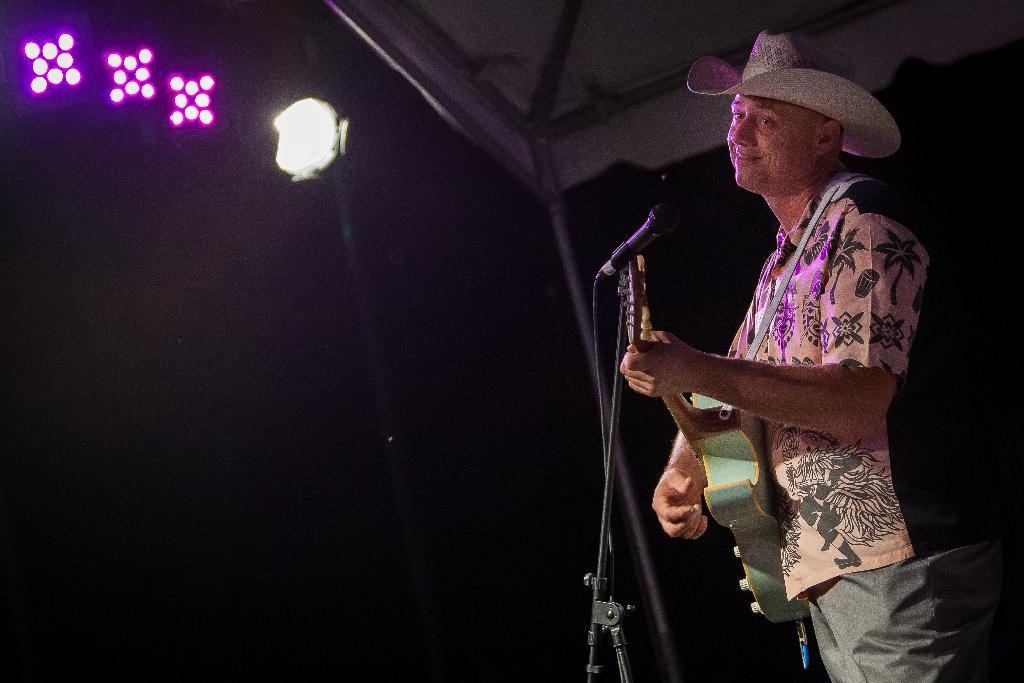What is the main subject of the image? The main subject of the image is a man. What is the man doing in the image? The man is standing in the image. What object is the man holding in his hand? The man is holding a guitar in his hand. What type of insect can be seen crawling on the man's guitar in the image? There is no insect present on the guitar in the image. How many steps does the man need to take to reach the school in the image? There is no school present in the image, and therefore no steps to reach it. 